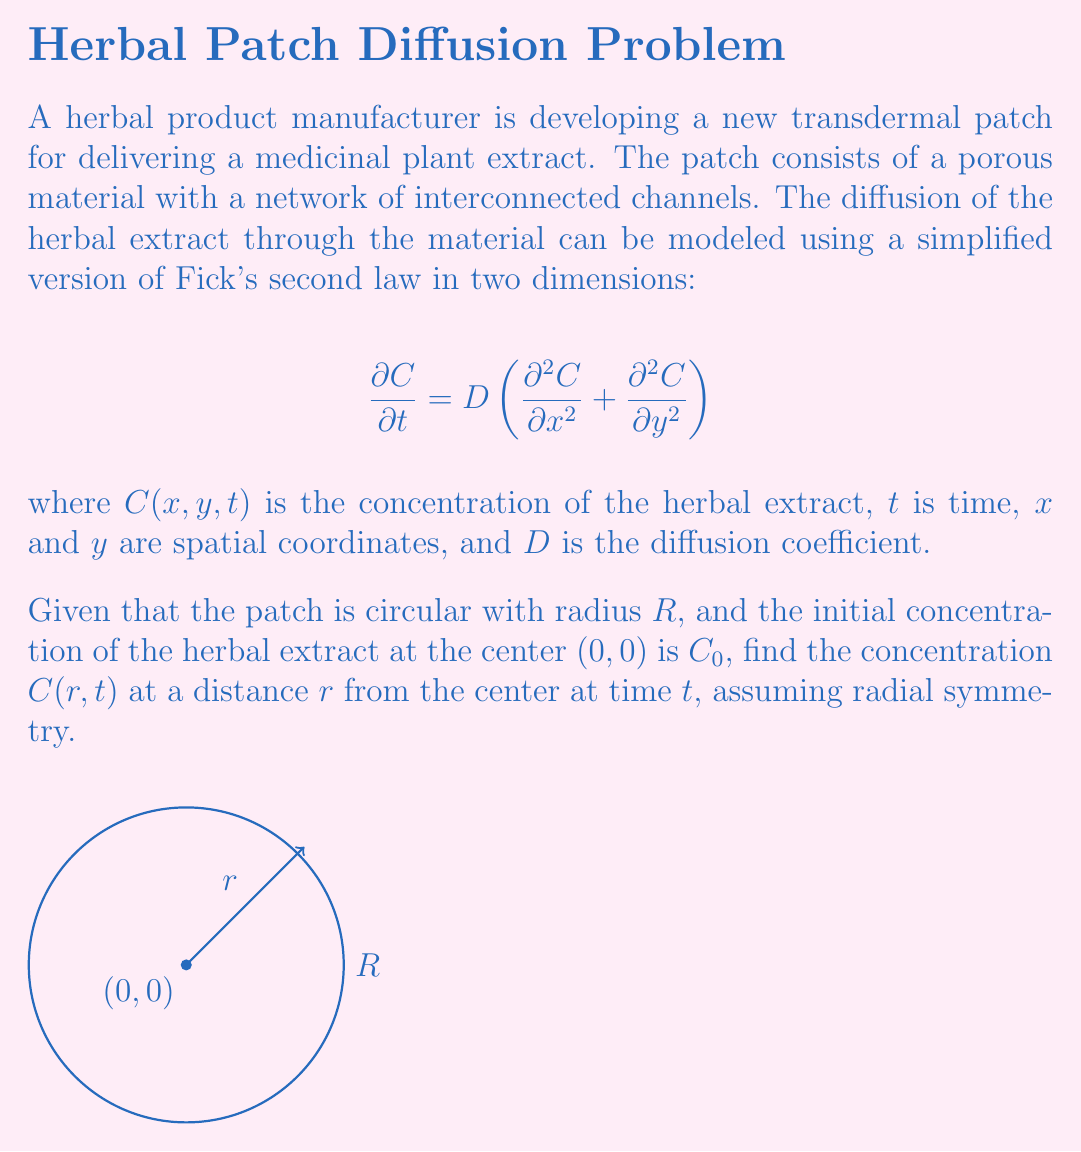What is the answer to this math problem? To solve this problem, we'll follow these steps:

1) First, we need to convert the equation from Cartesian coordinates $(x,y)$ to polar coordinates $(r,\theta)$ due to the radial symmetry of the problem.

2) In polar coordinates, with radial symmetry (no dependence on $\theta$), Fick's second law becomes:

   $$\frac{\partial C}{\partial t} = D\left(\frac{\partial^2 C}{\partial r^2} + \frac{1}{r}\frac{\partial C}{\partial r}\right)$$

3) The initial condition is:
   
   $C(r,0) = C_0\delta(r)$, where $\delta(r)$ is the Dirac delta function.

4) The boundary condition is:
   
   $C(R,t) = 0$ for all $t > 0$

5) The solution to this equation with these conditions is:

   $$C(r,t) = \frac{C_0}{4\pi Dt}\exp\left(-\frac{r^2}{4Dt}\right)$$

6) This solution satisfies the initial condition as $t \to 0$ and approaches zero as $r \to R$ for large $t$.

7) The factor $\frac{C_0}{4\pi Dt}$ ensures that the total amount of herbal extract remains constant (conserved) over time.

This solution describes how the concentration of the herbal extract changes with distance from the center and time, allowing the manufacturer to predict the diffusion behavior in the transdermal patch.
Answer: $C(r,t) = \frac{C_0}{4\pi Dt}\exp\left(-\frac{r^2}{4Dt}\right)$ 